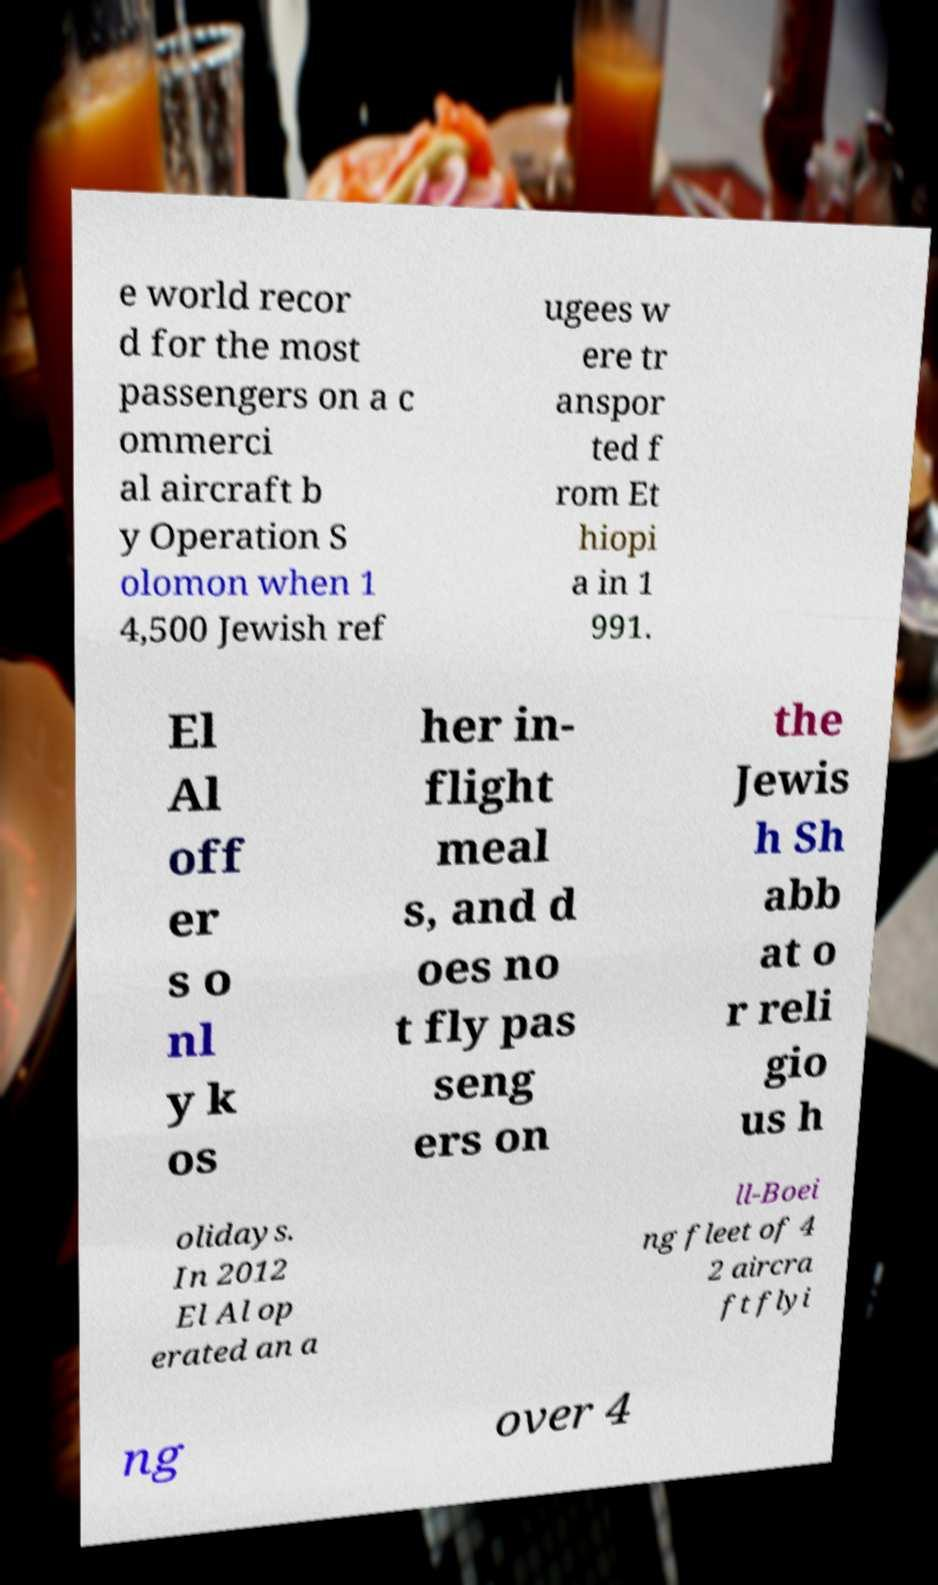Please identify and transcribe the text found in this image. e world recor d for the most passengers on a c ommerci al aircraft b y Operation S olomon when 1 4,500 Jewish ref ugees w ere tr anspor ted f rom Et hiopi a in 1 991. El Al off er s o nl y k os her in- flight meal s, and d oes no t fly pas seng ers on the Jewis h Sh abb at o r reli gio us h olidays. In 2012 El Al op erated an a ll-Boei ng fleet of 4 2 aircra ft flyi ng over 4 